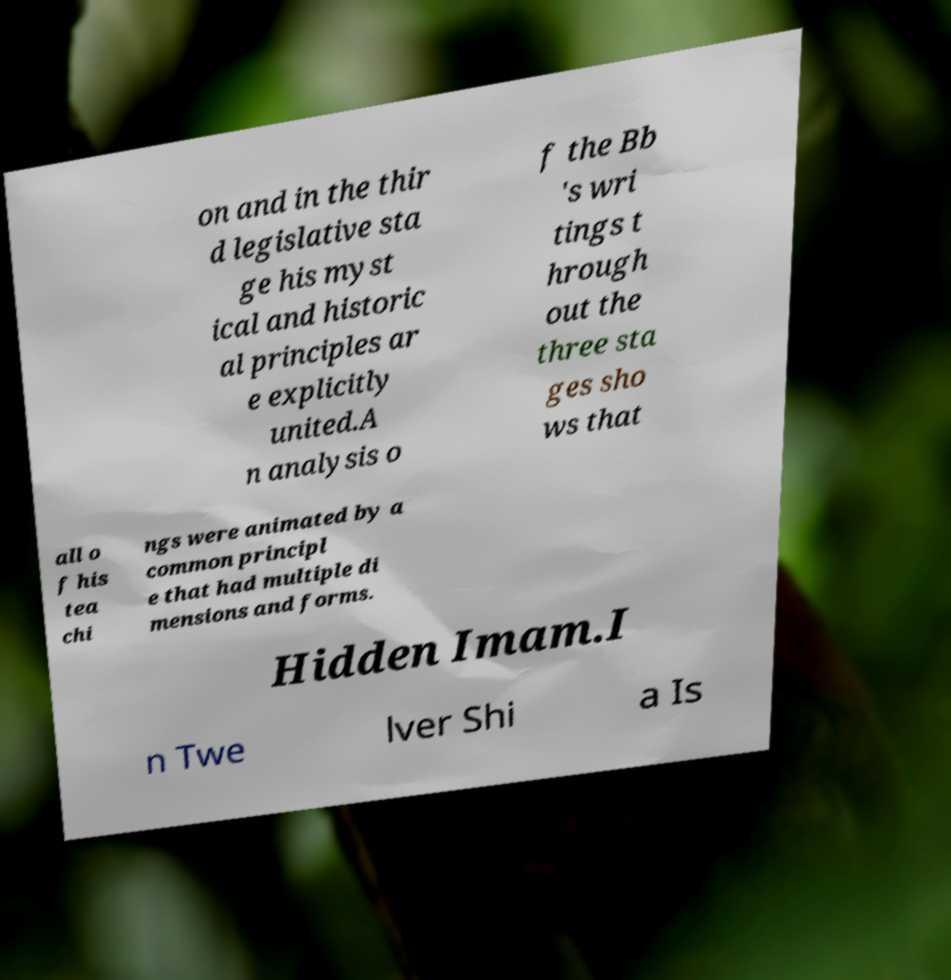For documentation purposes, I need the text within this image transcribed. Could you provide that? on and in the thir d legislative sta ge his myst ical and historic al principles ar e explicitly united.A n analysis o f the Bb 's wri tings t hrough out the three sta ges sho ws that all o f his tea chi ngs were animated by a common principl e that had multiple di mensions and forms. Hidden Imam.I n Twe lver Shi a Is 